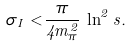<formula> <loc_0><loc_0><loc_500><loc_500>\sigma _ { I } < \frac { \pi } { 4 m _ { \pi } ^ { 2 } } \, \ln ^ { 2 } s .</formula> 